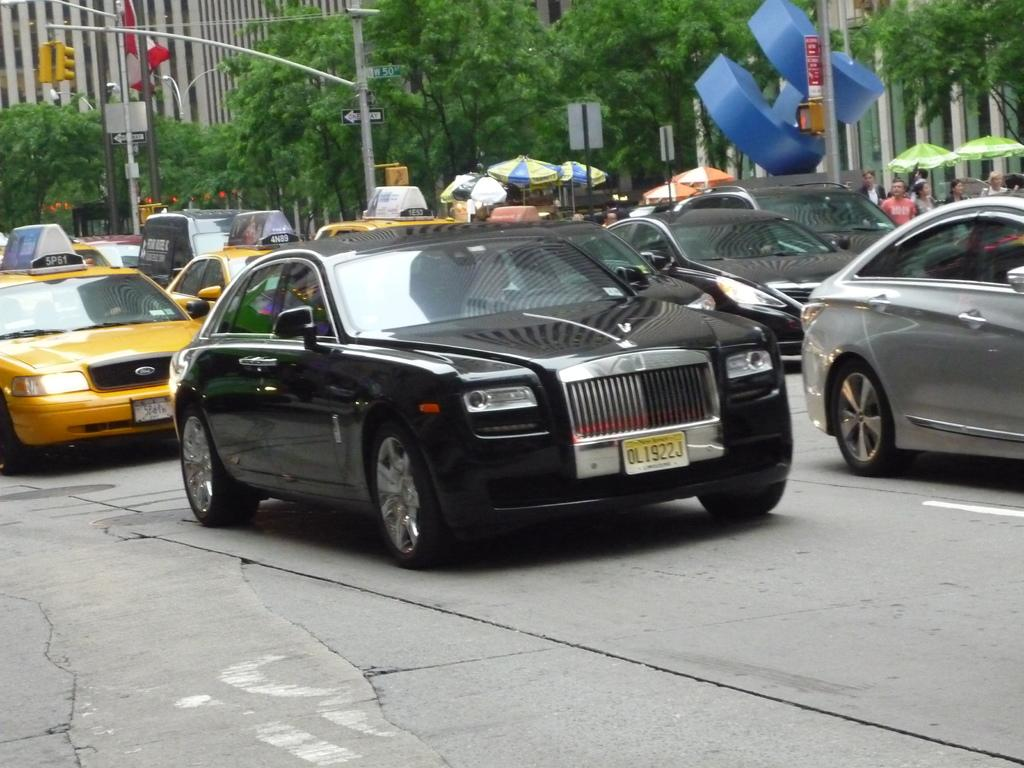<image>
Relay a brief, clear account of the picture shown. A black luxury vehicle with the license plate OL1922J. 